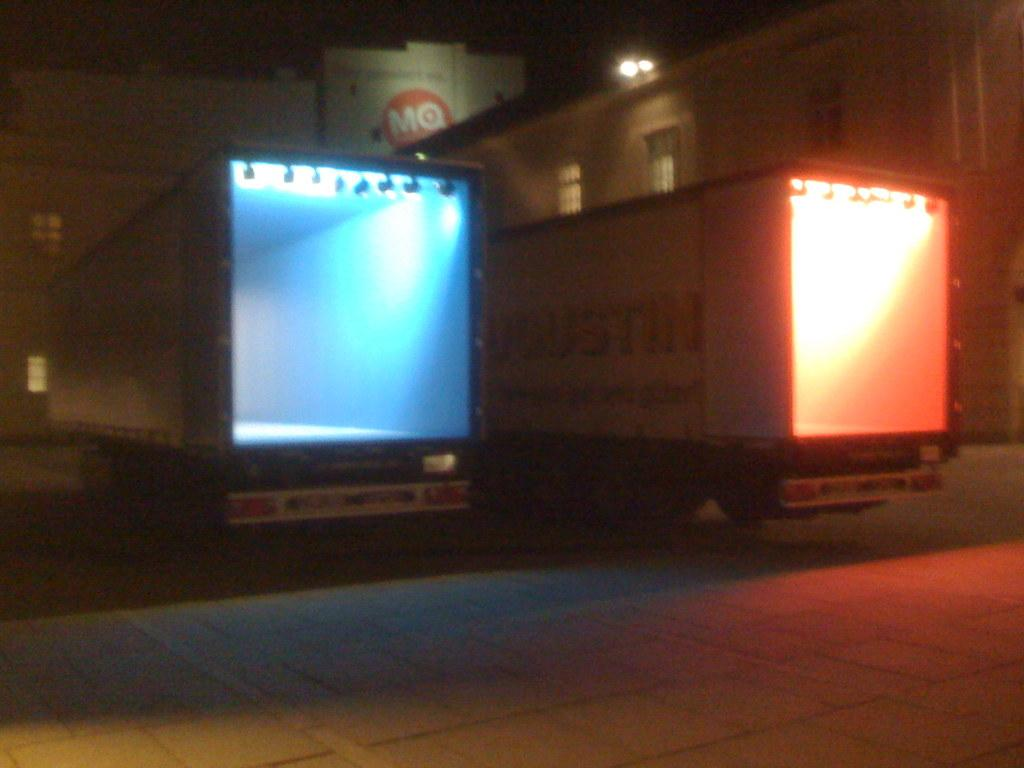<image>
Offer a succinct explanation of the picture presented. A truck outside a building with the letters MQ painted on it. 